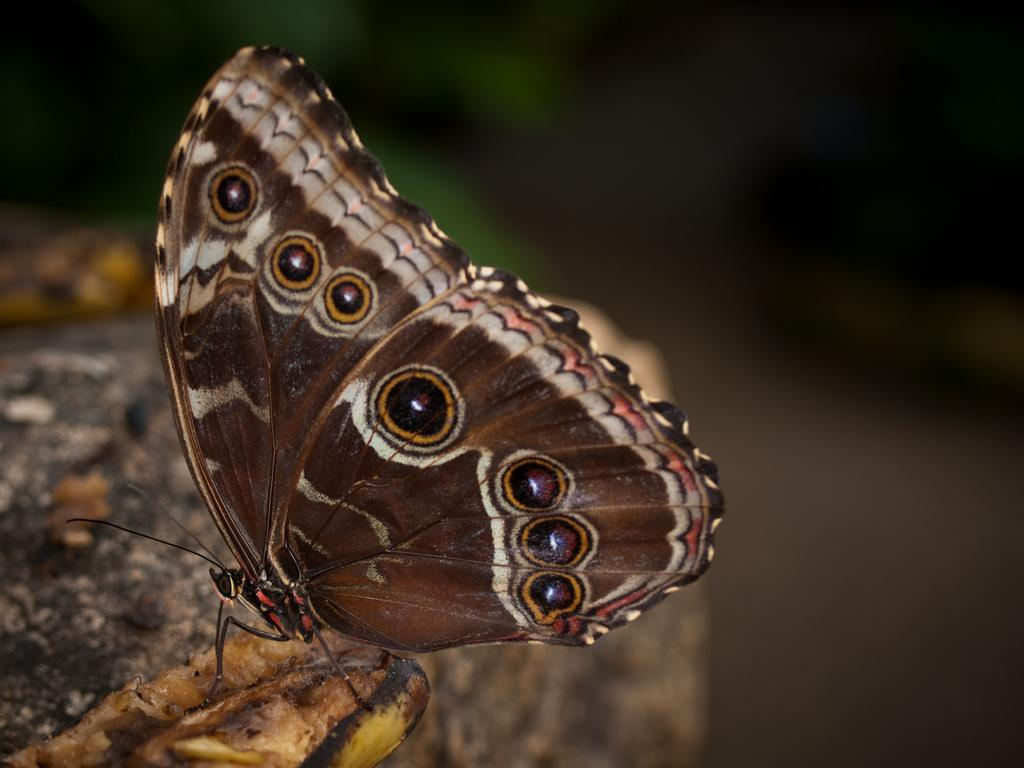What is the main subject in the foreground of the image? There is a butterfly in the foreground of the image. What can be seen in the background of the image? There are trees and stones in the background of the image. What is the opinion of the leaf in the image? There is no leaf present in the image, so it is not possible to determine its opinion. 